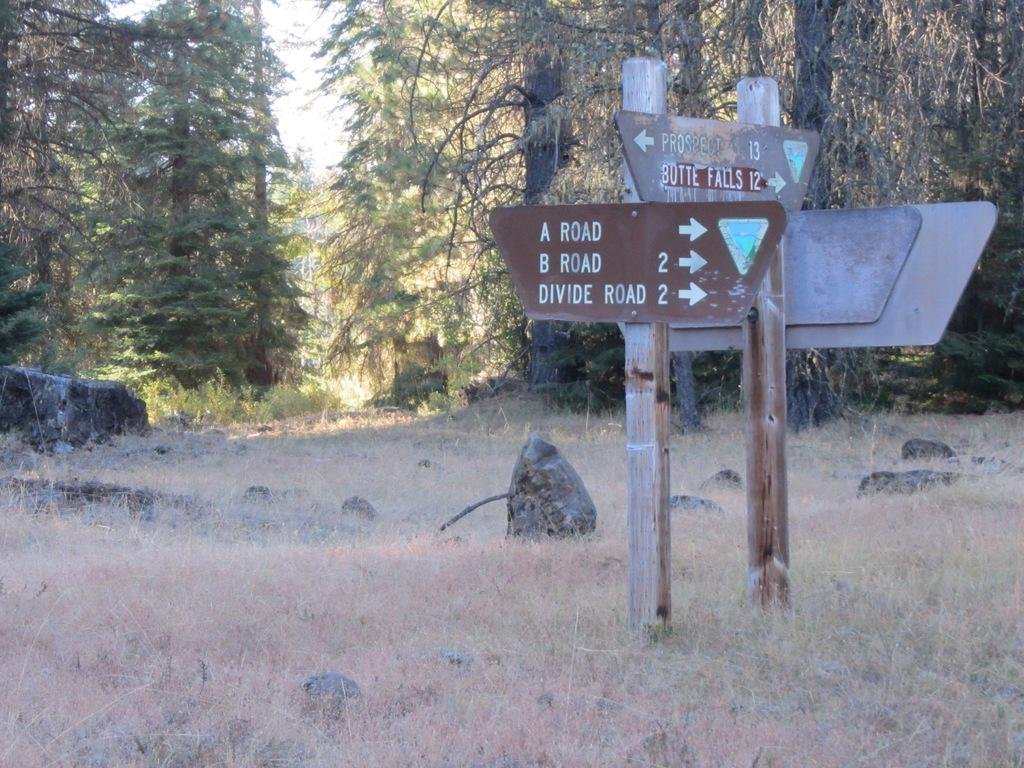What type of vegetation can be seen in the background of the image? There are trees in the background of the image. What type of terrain is visible in the image? There are rocks and grass visible in the image. What type of structures are present in the image? There are boards and poles in the image. How many rabbits can be seen hopping around in the image? There are no rabbits present in the image. What type of boundary is visible in the image? There is no boundary visible in the image. Can you tell me the color of the pig in the image? There is no pig present in the image. 